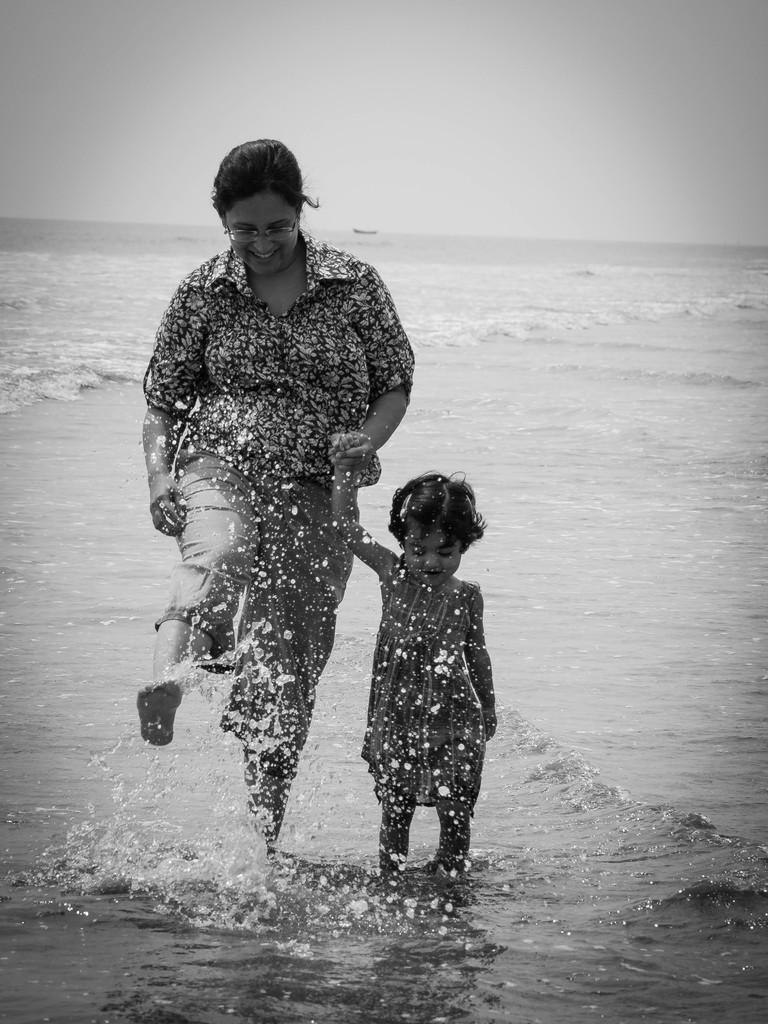What is the color scheme of the image? The image is black and white. Who can be seen in the image? There is a lady and a girl in the image. Where is the scene taking place? The setting is a beach. What type of drum can be seen in the image? There is no drum present in the image. What material is the girl's quiver made of in the image? There is no quiver present in the image. 